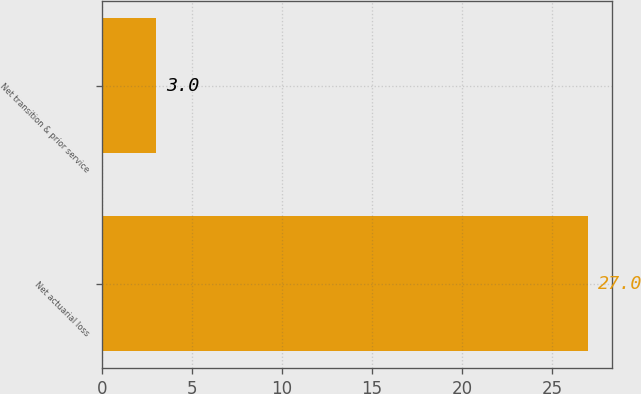<chart> <loc_0><loc_0><loc_500><loc_500><bar_chart><fcel>Net actuarial loss<fcel>Net transition & prior service<nl><fcel>27<fcel>3<nl></chart> 